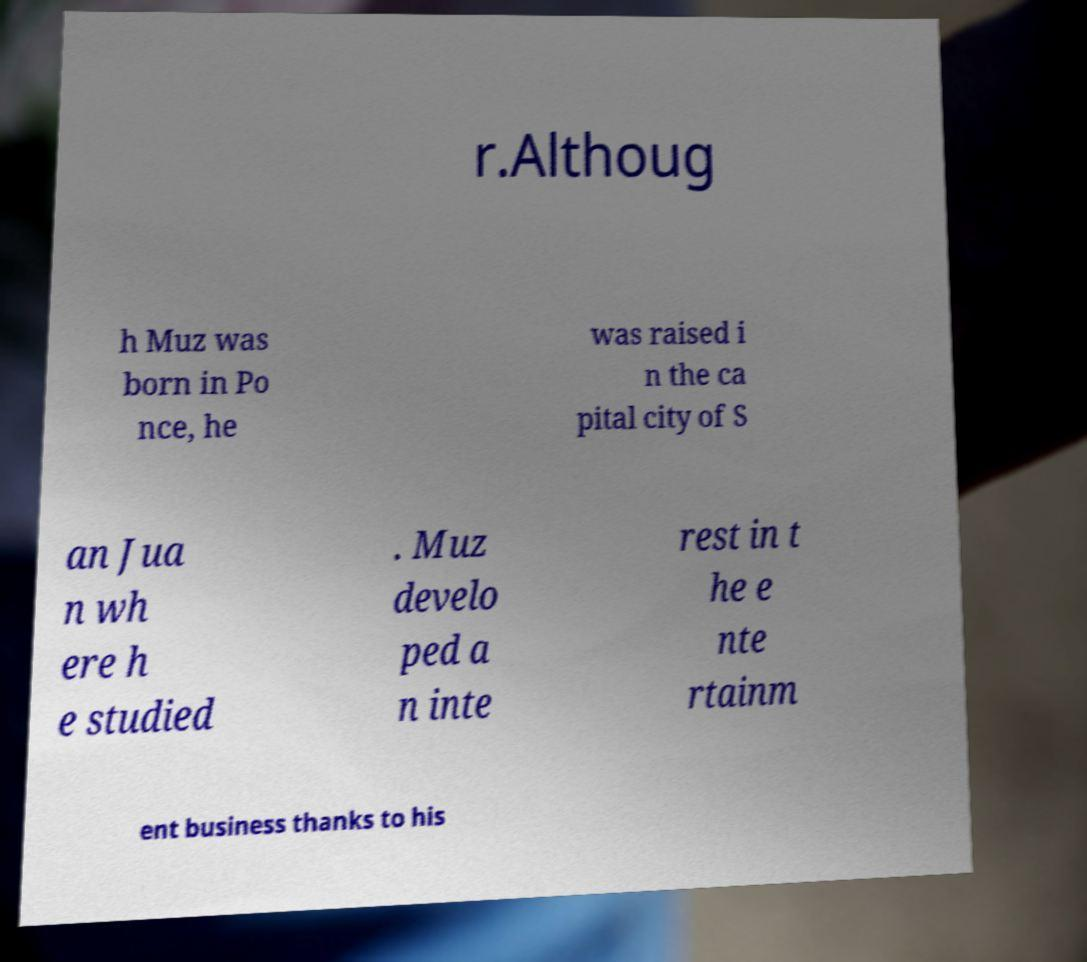Please identify and transcribe the text found in this image. r.Althoug h Muz was born in Po nce, he was raised i n the ca pital city of S an Jua n wh ere h e studied . Muz develo ped a n inte rest in t he e nte rtainm ent business thanks to his 